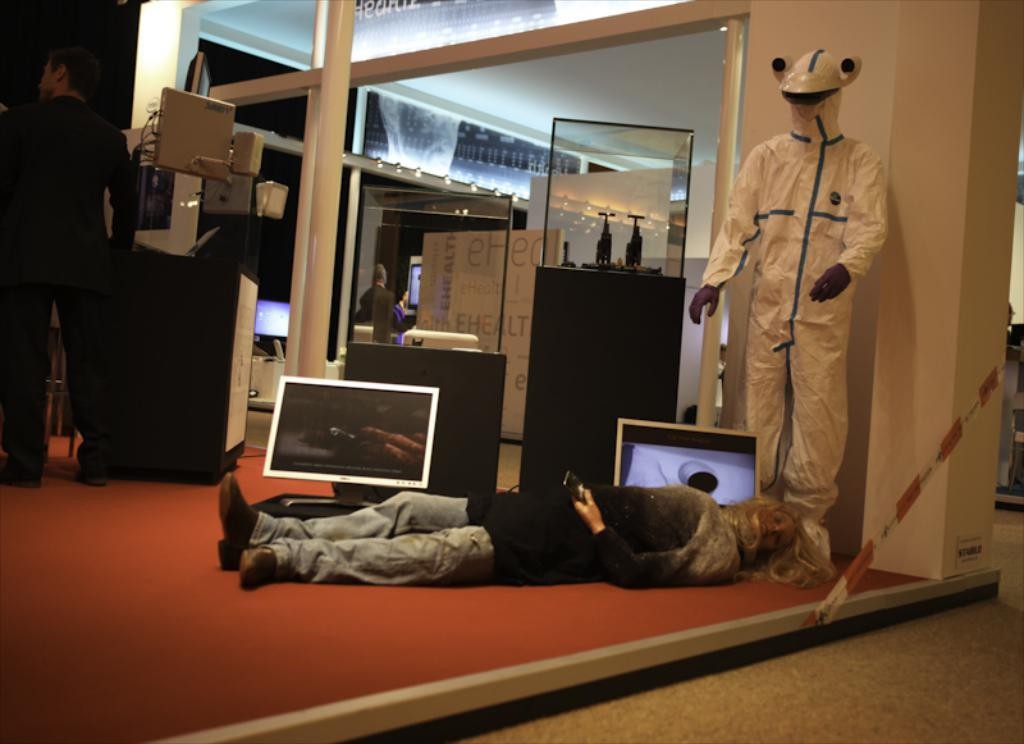What is the position of the person in the image? There is a person lying down in the image. What can be seen in the background of the image? There are people, systems, and glass objects visible in the background of the image. What is the color of the wall in the image? The wall is white in color. What flavor of ice cream is the person eating in the cave? There is no ice cream present in the image, and the setting does not resemble a cave. 